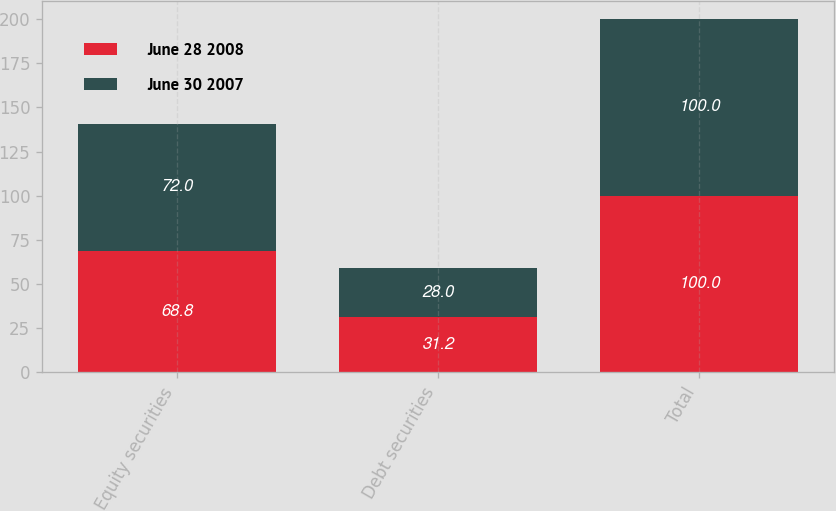Convert chart. <chart><loc_0><loc_0><loc_500><loc_500><stacked_bar_chart><ecel><fcel>Equity securities<fcel>Debt securities<fcel>Total<nl><fcel>June 28 2008<fcel>68.8<fcel>31.2<fcel>100<nl><fcel>June 30 2007<fcel>72<fcel>28<fcel>100<nl></chart> 